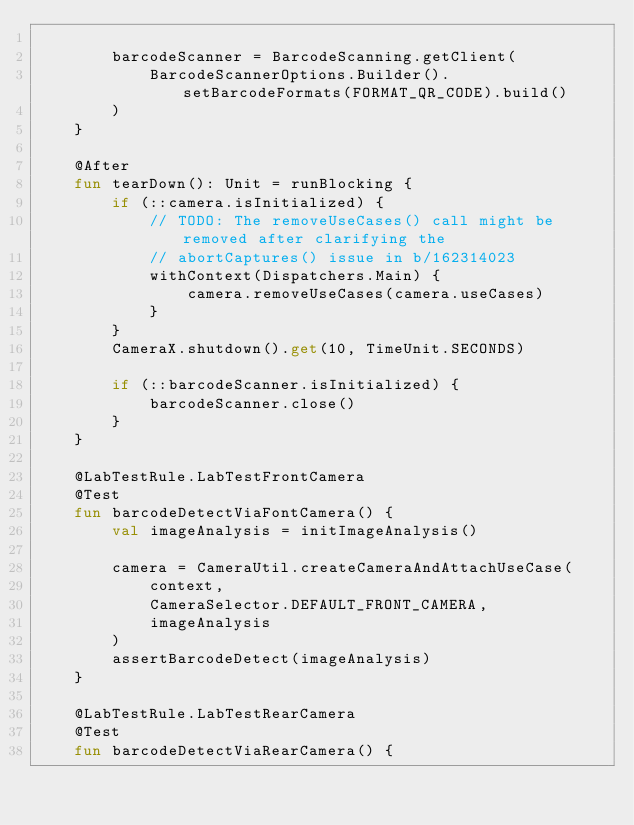<code> <loc_0><loc_0><loc_500><loc_500><_Kotlin_>
        barcodeScanner = BarcodeScanning.getClient(
            BarcodeScannerOptions.Builder().setBarcodeFormats(FORMAT_QR_CODE).build()
        )
    }

    @After
    fun tearDown(): Unit = runBlocking {
        if (::camera.isInitialized) {
            // TODO: The removeUseCases() call might be removed after clarifying the
            // abortCaptures() issue in b/162314023
            withContext(Dispatchers.Main) {
                camera.removeUseCases(camera.useCases)
            }
        }
        CameraX.shutdown().get(10, TimeUnit.SECONDS)

        if (::barcodeScanner.isInitialized) {
            barcodeScanner.close()
        }
    }

    @LabTestRule.LabTestFrontCamera
    @Test
    fun barcodeDetectViaFontCamera() {
        val imageAnalysis = initImageAnalysis()

        camera = CameraUtil.createCameraAndAttachUseCase(
            context,
            CameraSelector.DEFAULT_FRONT_CAMERA,
            imageAnalysis
        )
        assertBarcodeDetect(imageAnalysis)
    }

    @LabTestRule.LabTestRearCamera
    @Test
    fun barcodeDetectViaRearCamera() {</code> 